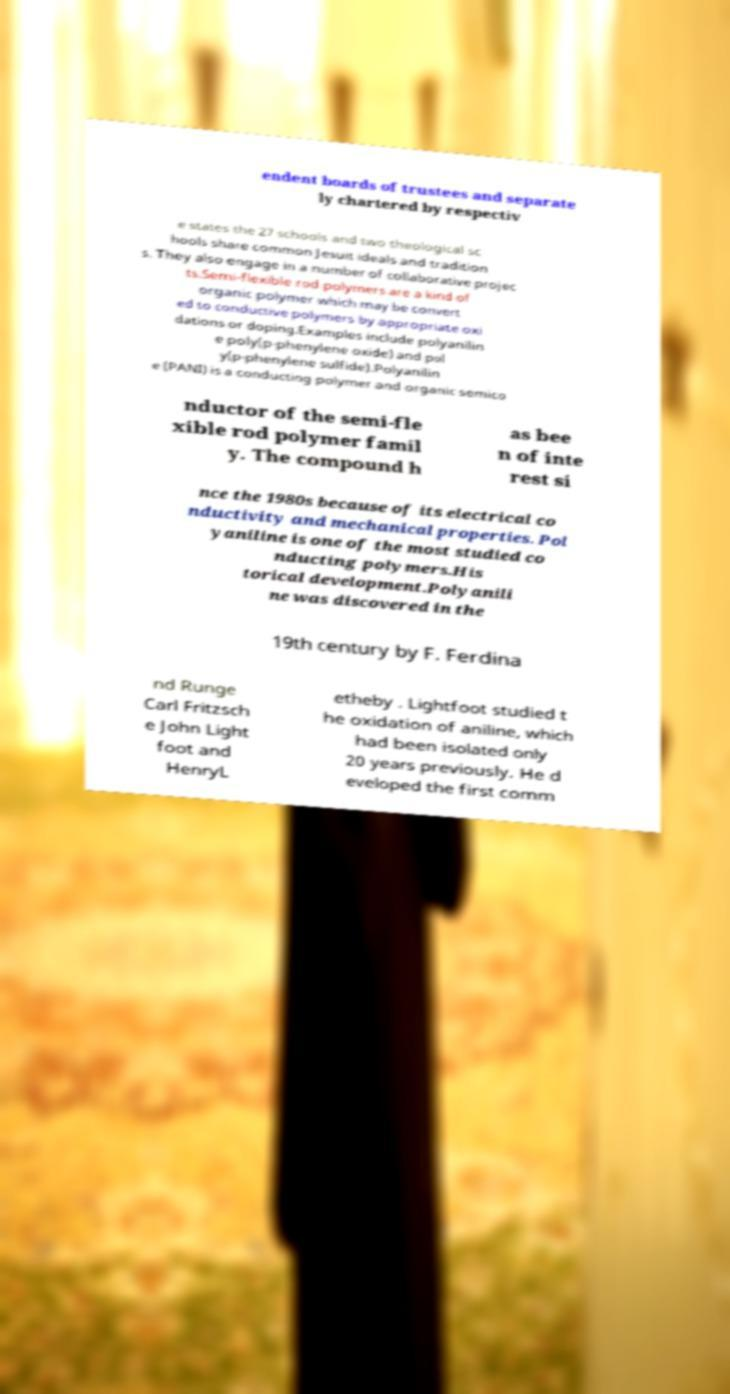There's text embedded in this image that I need extracted. Can you transcribe it verbatim? endent boards of trustees and separate ly chartered by respectiv e states the 27 schools and two theological sc hools share common Jesuit ideals and tradition s. They also engage in a number of collaborative projec ts.Semi-flexible rod polymers are a kind of organic polymer which may be convert ed to conductive polymers by appropriate oxi dations or doping.Examples include polyanilin e poly(p-phenylene oxide) and pol y(p-phenylene sulfide).Polyanilin e (PANI) is a conducting polymer and organic semico nductor of the semi-fle xible rod polymer famil y. The compound h as bee n of inte rest si nce the 1980s because of its electrical co nductivity and mechanical properties. Pol yaniline is one of the most studied co nducting polymers.His torical development.Polyanili ne was discovered in the 19th century by F. Ferdina nd Runge Carl Fritzsch e John Light foot and HenryL etheby . Lightfoot studied t he oxidation of aniline, which had been isolated only 20 years previously. He d eveloped the first comm 